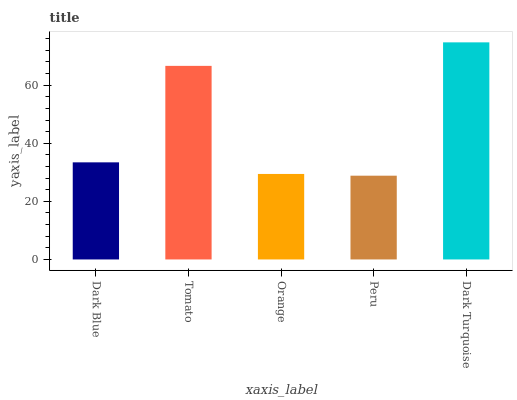Is Peru the minimum?
Answer yes or no. Yes. Is Dark Turquoise the maximum?
Answer yes or no. Yes. Is Tomato the minimum?
Answer yes or no. No. Is Tomato the maximum?
Answer yes or no. No. Is Tomato greater than Dark Blue?
Answer yes or no. Yes. Is Dark Blue less than Tomato?
Answer yes or no. Yes. Is Dark Blue greater than Tomato?
Answer yes or no. No. Is Tomato less than Dark Blue?
Answer yes or no. No. Is Dark Blue the high median?
Answer yes or no. Yes. Is Dark Blue the low median?
Answer yes or no. Yes. Is Dark Turquoise the high median?
Answer yes or no. No. Is Orange the low median?
Answer yes or no. No. 